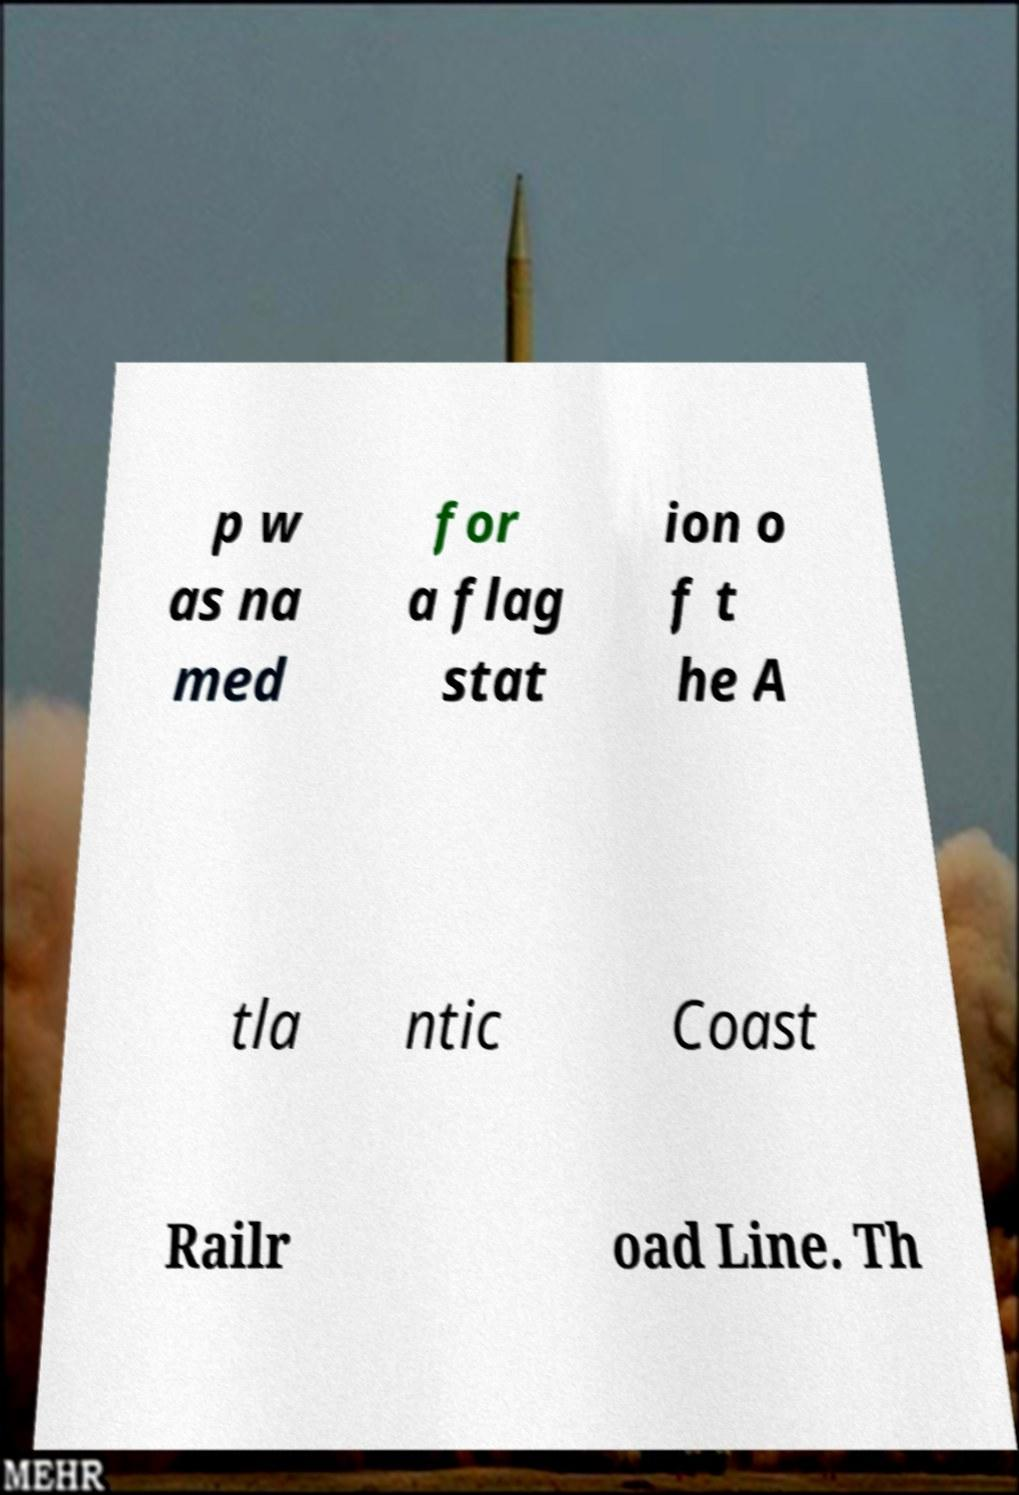For documentation purposes, I need the text within this image transcribed. Could you provide that? p w as na med for a flag stat ion o f t he A tla ntic Coast Railr oad Line. Th 